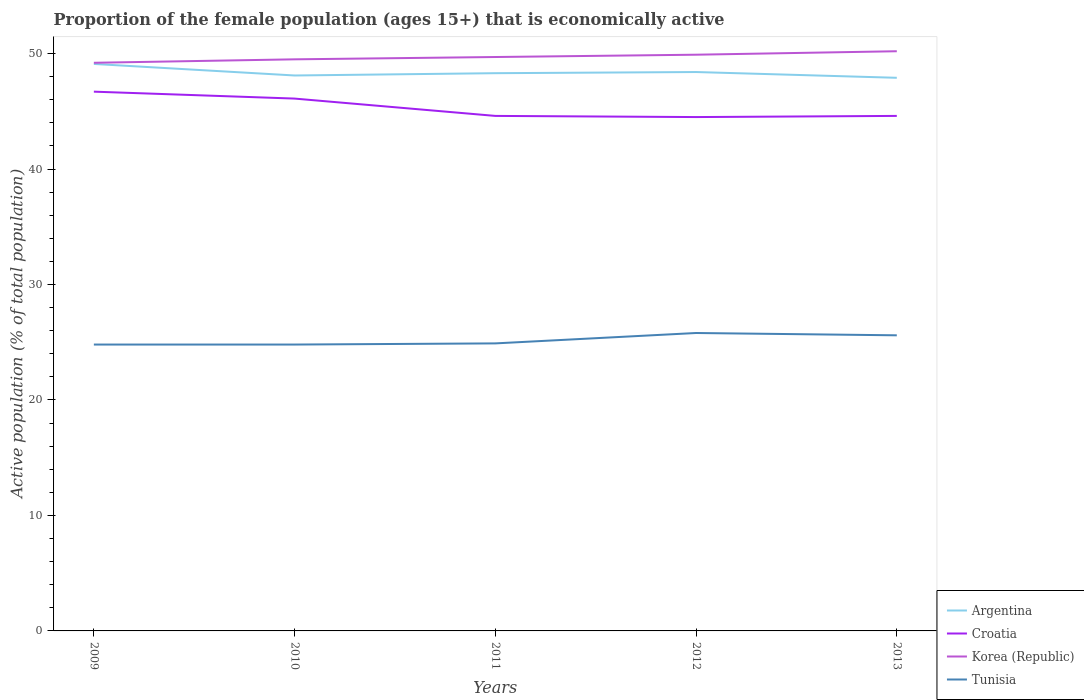How many different coloured lines are there?
Provide a succinct answer. 4. Across all years, what is the maximum proportion of the female population that is economically active in Croatia?
Offer a terse response. 44.5. What is the total proportion of the female population that is economically active in Tunisia in the graph?
Give a very brief answer. -0.7. What is the difference between the highest and the lowest proportion of the female population that is economically active in Tunisia?
Your answer should be very brief. 2. How many lines are there?
Provide a short and direct response. 4. How many years are there in the graph?
Ensure brevity in your answer.  5. Are the values on the major ticks of Y-axis written in scientific E-notation?
Your response must be concise. No. Where does the legend appear in the graph?
Make the answer very short. Bottom right. How many legend labels are there?
Make the answer very short. 4. What is the title of the graph?
Offer a very short reply. Proportion of the female population (ages 15+) that is economically active. What is the label or title of the X-axis?
Offer a terse response. Years. What is the label or title of the Y-axis?
Offer a very short reply. Active population (% of total population). What is the Active population (% of total population) in Argentina in 2009?
Give a very brief answer. 49.1. What is the Active population (% of total population) in Croatia in 2009?
Provide a succinct answer. 46.7. What is the Active population (% of total population) in Korea (Republic) in 2009?
Give a very brief answer. 49.2. What is the Active population (% of total population) in Tunisia in 2009?
Your answer should be very brief. 24.8. What is the Active population (% of total population) in Argentina in 2010?
Your answer should be compact. 48.1. What is the Active population (% of total population) in Croatia in 2010?
Your answer should be very brief. 46.1. What is the Active population (% of total population) of Korea (Republic) in 2010?
Offer a terse response. 49.5. What is the Active population (% of total population) in Tunisia in 2010?
Ensure brevity in your answer.  24.8. What is the Active population (% of total population) in Argentina in 2011?
Provide a short and direct response. 48.3. What is the Active population (% of total population) in Croatia in 2011?
Offer a very short reply. 44.6. What is the Active population (% of total population) in Korea (Republic) in 2011?
Your response must be concise. 49.7. What is the Active population (% of total population) in Tunisia in 2011?
Keep it short and to the point. 24.9. What is the Active population (% of total population) of Argentina in 2012?
Your response must be concise. 48.4. What is the Active population (% of total population) in Croatia in 2012?
Ensure brevity in your answer.  44.5. What is the Active population (% of total population) of Korea (Republic) in 2012?
Keep it short and to the point. 49.9. What is the Active population (% of total population) of Tunisia in 2012?
Keep it short and to the point. 25.8. What is the Active population (% of total population) of Argentina in 2013?
Ensure brevity in your answer.  47.9. What is the Active population (% of total population) of Croatia in 2013?
Your answer should be very brief. 44.6. What is the Active population (% of total population) in Korea (Republic) in 2013?
Your answer should be compact. 50.2. What is the Active population (% of total population) of Tunisia in 2013?
Your answer should be compact. 25.6. Across all years, what is the maximum Active population (% of total population) in Argentina?
Your response must be concise. 49.1. Across all years, what is the maximum Active population (% of total population) in Croatia?
Give a very brief answer. 46.7. Across all years, what is the maximum Active population (% of total population) in Korea (Republic)?
Offer a terse response. 50.2. Across all years, what is the maximum Active population (% of total population) in Tunisia?
Provide a succinct answer. 25.8. Across all years, what is the minimum Active population (% of total population) in Argentina?
Offer a terse response. 47.9. Across all years, what is the minimum Active population (% of total population) of Croatia?
Ensure brevity in your answer.  44.5. Across all years, what is the minimum Active population (% of total population) in Korea (Republic)?
Provide a succinct answer. 49.2. Across all years, what is the minimum Active population (% of total population) of Tunisia?
Offer a terse response. 24.8. What is the total Active population (% of total population) of Argentina in the graph?
Provide a short and direct response. 241.8. What is the total Active population (% of total population) in Croatia in the graph?
Provide a succinct answer. 226.5. What is the total Active population (% of total population) of Korea (Republic) in the graph?
Your response must be concise. 248.5. What is the total Active population (% of total population) of Tunisia in the graph?
Offer a terse response. 125.9. What is the difference between the Active population (% of total population) of Argentina in 2009 and that in 2010?
Make the answer very short. 1. What is the difference between the Active population (% of total population) in Korea (Republic) in 2009 and that in 2010?
Make the answer very short. -0.3. What is the difference between the Active population (% of total population) in Croatia in 2009 and that in 2011?
Your answer should be compact. 2.1. What is the difference between the Active population (% of total population) of Tunisia in 2009 and that in 2011?
Provide a short and direct response. -0.1. What is the difference between the Active population (% of total population) of Korea (Republic) in 2010 and that in 2011?
Offer a terse response. -0.2. What is the difference between the Active population (% of total population) in Croatia in 2010 and that in 2012?
Offer a very short reply. 1.6. What is the difference between the Active population (% of total population) of Korea (Republic) in 2010 and that in 2012?
Offer a terse response. -0.4. What is the difference between the Active population (% of total population) in Argentina in 2010 and that in 2013?
Your answer should be compact. 0.2. What is the difference between the Active population (% of total population) of Croatia in 2010 and that in 2013?
Provide a short and direct response. 1.5. What is the difference between the Active population (% of total population) in Tunisia in 2010 and that in 2013?
Your answer should be compact. -0.8. What is the difference between the Active population (% of total population) of Korea (Republic) in 2011 and that in 2012?
Give a very brief answer. -0.2. What is the difference between the Active population (% of total population) of Tunisia in 2011 and that in 2012?
Provide a succinct answer. -0.9. What is the difference between the Active population (% of total population) of Argentina in 2011 and that in 2013?
Offer a very short reply. 0.4. What is the difference between the Active population (% of total population) of Korea (Republic) in 2011 and that in 2013?
Make the answer very short. -0.5. What is the difference between the Active population (% of total population) in Tunisia in 2011 and that in 2013?
Your response must be concise. -0.7. What is the difference between the Active population (% of total population) in Tunisia in 2012 and that in 2013?
Offer a very short reply. 0.2. What is the difference between the Active population (% of total population) in Argentina in 2009 and the Active population (% of total population) in Croatia in 2010?
Make the answer very short. 3. What is the difference between the Active population (% of total population) of Argentina in 2009 and the Active population (% of total population) of Korea (Republic) in 2010?
Keep it short and to the point. -0.4. What is the difference between the Active population (% of total population) in Argentina in 2009 and the Active population (% of total population) in Tunisia in 2010?
Make the answer very short. 24.3. What is the difference between the Active population (% of total population) of Croatia in 2009 and the Active population (% of total population) of Korea (Republic) in 2010?
Keep it short and to the point. -2.8. What is the difference between the Active population (% of total population) of Croatia in 2009 and the Active population (% of total population) of Tunisia in 2010?
Make the answer very short. 21.9. What is the difference between the Active population (% of total population) in Korea (Republic) in 2009 and the Active population (% of total population) in Tunisia in 2010?
Provide a short and direct response. 24.4. What is the difference between the Active population (% of total population) of Argentina in 2009 and the Active population (% of total population) of Croatia in 2011?
Ensure brevity in your answer.  4.5. What is the difference between the Active population (% of total population) of Argentina in 2009 and the Active population (% of total population) of Korea (Republic) in 2011?
Make the answer very short. -0.6. What is the difference between the Active population (% of total population) of Argentina in 2009 and the Active population (% of total population) of Tunisia in 2011?
Your answer should be compact. 24.2. What is the difference between the Active population (% of total population) of Croatia in 2009 and the Active population (% of total population) of Korea (Republic) in 2011?
Make the answer very short. -3. What is the difference between the Active population (% of total population) in Croatia in 2009 and the Active population (% of total population) in Tunisia in 2011?
Your answer should be very brief. 21.8. What is the difference between the Active population (% of total population) of Korea (Republic) in 2009 and the Active population (% of total population) of Tunisia in 2011?
Make the answer very short. 24.3. What is the difference between the Active population (% of total population) of Argentina in 2009 and the Active population (% of total population) of Korea (Republic) in 2012?
Keep it short and to the point. -0.8. What is the difference between the Active population (% of total population) of Argentina in 2009 and the Active population (% of total population) of Tunisia in 2012?
Your answer should be very brief. 23.3. What is the difference between the Active population (% of total population) in Croatia in 2009 and the Active population (% of total population) in Korea (Republic) in 2012?
Provide a short and direct response. -3.2. What is the difference between the Active population (% of total population) of Croatia in 2009 and the Active population (% of total population) of Tunisia in 2012?
Offer a terse response. 20.9. What is the difference between the Active population (% of total population) of Korea (Republic) in 2009 and the Active population (% of total population) of Tunisia in 2012?
Keep it short and to the point. 23.4. What is the difference between the Active population (% of total population) of Argentina in 2009 and the Active population (% of total population) of Croatia in 2013?
Your response must be concise. 4.5. What is the difference between the Active population (% of total population) of Argentina in 2009 and the Active population (% of total population) of Korea (Republic) in 2013?
Provide a short and direct response. -1.1. What is the difference between the Active population (% of total population) in Croatia in 2009 and the Active population (% of total population) in Korea (Republic) in 2013?
Make the answer very short. -3.5. What is the difference between the Active population (% of total population) of Croatia in 2009 and the Active population (% of total population) of Tunisia in 2013?
Offer a very short reply. 21.1. What is the difference between the Active population (% of total population) of Korea (Republic) in 2009 and the Active population (% of total population) of Tunisia in 2013?
Your answer should be very brief. 23.6. What is the difference between the Active population (% of total population) of Argentina in 2010 and the Active population (% of total population) of Korea (Republic) in 2011?
Keep it short and to the point. -1.6. What is the difference between the Active population (% of total population) of Argentina in 2010 and the Active population (% of total population) of Tunisia in 2011?
Offer a terse response. 23.2. What is the difference between the Active population (% of total population) in Croatia in 2010 and the Active population (% of total population) in Tunisia in 2011?
Provide a succinct answer. 21.2. What is the difference between the Active population (% of total population) in Korea (Republic) in 2010 and the Active population (% of total population) in Tunisia in 2011?
Give a very brief answer. 24.6. What is the difference between the Active population (% of total population) in Argentina in 2010 and the Active population (% of total population) in Tunisia in 2012?
Make the answer very short. 22.3. What is the difference between the Active population (% of total population) of Croatia in 2010 and the Active population (% of total population) of Korea (Republic) in 2012?
Offer a very short reply. -3.8. What is the difference between the Active population (% of total population) in Croatia in 2010 and the Active population (% of total population) in Tunisia in 2012?
Keep it short and to the point. 20.3. What is the difference between the Active population (% of total population) in Korea (Republic) in 2010 and the Active population (% of total population) in Tunisia in 2012?
Offer a terse response. 23.7. What is the difference between the Active population (% of total population) in Argentina in 2010 and the Active population (% of total population) in Korea (Republic) in 2013?
Give a very brief answer. -2.1. What is the difference between the Active population (% of total population) of Croatia in 2010 and the Active population (% of total population) of Korea (Republic) in 2013?
Give a very brief answer. -4.1. What is the difference between the Active population (% of total population) of Croatia in 2010 and the Active population (% of total population) of Tunisia in 2013?
Provide a succinct answer. 20.5. What is the difference between the Active population (% of total population) in Korea (Republic) in 2010 and the Active population (% of total population) in Tunisia in 2013?
Give a very brief answer. 23.9. What is the difference between the Active population (% of total population) of Argentina in 2011 and the Active population (% of total population) of Croatia in 2012?
Offer a terse response. 3.8. What is the difference between the Active population (% of total population) of Croatia in 2011 and the Active population (% of total population) of Korea (Republic) in 2012?
Offer a very short reply. -5.3. What is the difference between the Active population (% of total population) of Korea (Republic) in 2011 and the Active population (% of total population) of Tunisia in 2012?
Provide a short and direct response. 23.9. What is the difference between the Active population (% of total population) of Argentina in 2011 and the Active population (% of total population) of Korea (Republic) in 2013?
Provide a succinct answer. -1.9. What is the difference between the Active population (% of total population) of Argentina in 2011 and the Active population (% of total population) of Tunisia in 2013?
Offer a very short reply. 22.7. What is the difference between the Active population (% of total population) in Croatia in 2011 and the Active population (% of total population) in Tunisia in 2013?
Your response must be concise. 19. What is the difference between the Active population (% of total population) in Korea (Republic) in 2011 and the Active population (% of total population) in Tunisia in 2013?
Your response must be concise. 24.1. What is the difference between the Active population (% of total population) of Argentina in 2012 and the Active population (% of total population) of Croatia in 2013?
Keep it short and to the point. 3.8. What is the difference between the Active population (% of total population) of Argentina in 2012 and the Active population (% of total population) of Tunisia in 2013?
Give a very brief answer. 22.8. What is the difference between the Active population (% of total population) of Korea (Republic) in 2012 and the Active population (% of total population) of Tunisia in 2013?
Provide a short and direct response. 24.3. What is the average Active population (% of total population) of Argentina per year?
Ensure brevity in your answer.  48.36. What is the average Active population (% of total population) of Croatia per year?
Make the answer very short. 45.3. What is the average Active population (% of total population) in Korea (Republic) per year?
Your response must be concise. 49.7. What is the average Active population (% of total population) in Tunisia per year?
Provide a succinct answer. 25.18. In the year 2009, what is the difference between the Active population (% of total population) in Argentina and Active population (% of total population) in Tunisia?
Keep it short and to the point. 24.3. In the year 2009, what is the difference between the Active population (% of total population) in Croatia and Active population (% of total population) in Tunisia?
Provide a short and direct response. 21.9. In the year 2009, what is the difference between the Active population (% of total population) of Korea (Republic) and Active population (% of total population) of Tunisia?
Your answer should be very brief. 24.4. In the year 2010, what is the difference between the Active population (% of total population) in Argentina and Active population (% of total population) in Tunisia?
Offer a very short reply. 23.3. In the year 2010, what is the difference between the Active population (% of total population) of Croatia and Active population (% of total population) of Tunisia?
Keep it short and to the point. 21.3. In the year 2010, what is the difference between the Active population (% of total population) of Korea (Republic) and Active population (% of total population) of Tunisia?
Offer a terse response. 24.7. In the year 2011, what is the difference between the Active population (% of total population) of Argentina and Active population (% of total population) of Korea (Republic)?
Provide a succinct answer. -1.4. In the year 2011, what is the difference between the Active population (% of total population) in Argentina and Active population (% of total population) in Tunisia?
Provide a succinct answer. 23.4. In the year 2011, what is the difference between the Active population (% of total population) of Croatia and Active population (% of total population) of Korea (Republic)?
Offer a terse response. -5.1. In the year 2011, what is the difference between the Active population (% of total population) in Korea (Republic) and Active population (% of total population) in Tunisia?
Your answer should be compact. 24.8. In the year 2012, what is the difference between the Active population (% of total population) in Argentina and Active population (% of total population) in Tunisia?
Keep it short and to the point. 22.6. In the year 2012, what is the difference between the Active population (% of total population) in Croatia and Active population (% of total population) in Korea (Republic)?
Give a very brief answer. -5.4. In the year 2012, what is the difference between the Active population (% of total population) of Croatia and Active population (% of total population) of Tunisia?
Keep it short and to the point. 18.7. In the year 2012, what is the difference between the Active population (% of total population) in Korea (Republic) and Active population (% of total population) in Tunisia?
Keep it short and to the point. 24.1. In the year 2013, what is the difference between the Active population (% of total population) of Argentina and Active population (% of total population) of Croatia?
Your answer should be very brief. 3.3. In the year 2013, what is the difference between the Active population (% of total population) in Argentina and Active population (% of total population) in Tunisia?
Give a very brief answer. 22.3. In the year 2013, what is the difference between the Active population (% of total population) in Croatia and Active population (% of total population) in Korea (Republic)?
Your answer should be compact. -5.6. In the year 2013, what is the difference between the Active population (% of total population) of Korea (Republic) and Active population (% of total population) of Tunisia?
Keep it short and to the point. 24.6. What is the ratio of the Active population (% of total population) of Argentina in 2009 to that in 2010?
Your answer should be compact. 1.02. What is the ratio of the Active population (% of total population) of Croatia in 2009 to that in 2010?
Your answer should be compact. 1.01. What is the ratio of the Active population (% of total population) of Korea (Republic) in 2009 to that in 2010?
Make the answer very short. 0.99. What is the ratio of the Active population (% of total population) of Argentina in 2009 to that in 2011?
Your response must be concise. 1.02. What is the ratio of the Active population (% of total population) of Croatia in 2009 to that in 2011?
Provide a succinct answer. 1.05. What is the ratio of the Active population (% of total population) of Tunisia in 2009 to that in 2011?
Give a very brief answer. 1. What is the ratio of the Active population (% of total population) in Argentina in 2009 to that in 2012?
Provide a succinct answer. 1.01. What is the ratio of the Active population (% of total population) in Croatia in 2009 to that in 2012?
Give a very brief answer. 1.05. What is the ratio of the Active population (% of total population) of Korea (Republic) in 2009 to that in 2012?
Your response must be concise. 0.99. What is the ratio of the Active population (% of total population) in Tunisia in 2009 to that in 2012?
Give a very brief answer. 0.96. What is the ratio of the Active population (% of total population) of Argentina in 2009 to that in 2013?
Your response must be concise. 1.03. What is the ratio of the Active population (% of total population) of Croatia in 2009 to that in 2013?
Your response must be concise. 1.05. What is the ratio of the Active population (% of total population) of Korea (Republic) in 2009 to that in 2013?
Your answer should be very brief. 0.98. What is the ratio of the Active population (% of total population) of Tunisia in 2009 to that in 2013?
Provide a short and direct response. 0.97. What is the ratio of the Active population (% of total population) of Argentina in 2010 to that in 2011?
Offer a terse response. 1. What is the ratio of the Active population (% of total population) of Croatia in 2010 to that in 2011?
Provide a succinct answer. 1.03. What is the ratio of the Active population (% of total population) of Korea (Republic) in 2010 to that in 2011?
Give a very brief answer. 1. What is the ratio of the Active population (% of total population) of Tunisia in 2010 to that in 2011?
Your answer should be very brief. 1. What is the ratio of the Active population (% of total population) of Argentina in 2010 to that in 2012?
Keep it short and to the point. 0.99. What is the ratio of the Active population (% of total population) in Croatia in 2010 to that in 2012?
Provide a short and direct response. 1.04. What is the ratio of the Active population (% of total population) in Tunisia in 2010 to that in 2012?
Your answer should be compact. 0.96. What is the ratio of the Active population (% of total population) of Croatia in 2010 to that in 2013?
Keep it short and to the point. 1.03. What is the ratio of the Active population (% of total population) in Korea (Republic) in 2010 to that in 2013?
Offer a terse response. 0.99. What is the ratio of the Active population (% of total population) in Tunisia in 2010 to that in 2013?
Keep it short and to the point. 0.97. What is the ratio of the Active population (% of total population) of Korea (Republic) in 2011 to that in 2012?
Give a very brief answer. 1. What is the ratio of the Active population (% of total population) of Tunisia in 2011 to that in 2012?
Offer a terse response. 0.97. What is the ratio of the Active population (% of total population) of Argentina in 2011 to that in 2013?
Ensure brevity in your answer.  1.01. What is the ratio of the Active population (% of total population) of Tunisia in 2011 to that in 2013?
Keep it short and to the point. 0.97. What is the ratio of the Active population (% of total population) in Argentina in 2012 to that in 2013?
Keep it short and to the point. 1.01. What is the ratio of the Active population (% of total population) of Korea (Republic) in 2012 to that in 2013?
Your answer should be compact. 0.99. What is the ratio of the Active population (% of total population) in Tunisia in 2012 to that in 2013?
Make the answer very short. 1.01. What is the difference between the highest and the second highest Active population (% of total population) of Argentina?
Ensure brevity in your answer.  0.7. What is the difference between the highest and the second highest Active population (% of total population) in Croatia?
Keep it short and to the point. 0.6. What is the difference between the highest and the lowest Active population (% of total population) in Argentina?
Ensure brevity in your answer.  1.2. What is the difference between the highest and the lowest Active population (% of total population) of Croatia?
Ensure brevity in your answer.  2.2. What is the difference between the highest and the lowest Active population (% of total population) in Tunisia?
Give a very brief answer. 1. 